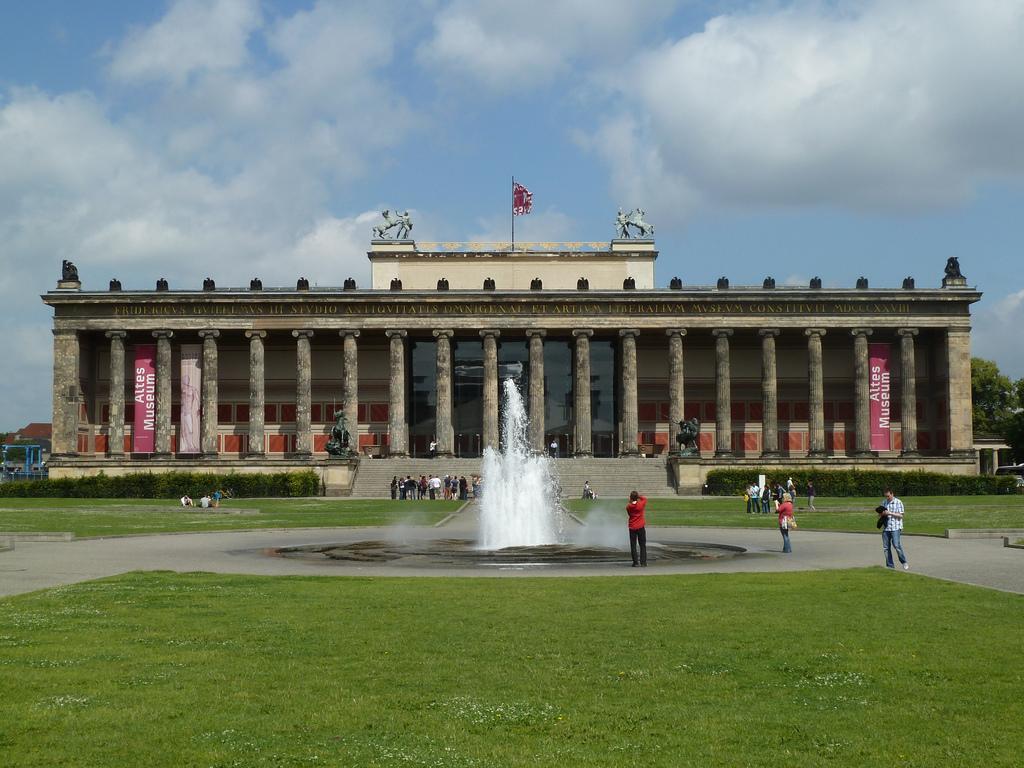Can you describe this image briefly? In the image we can see fort, pillars, banner, statues, flag, plant, stairs, grass, trees, water fountain and a cloudy sky. We can even see there are people, walking, standing and some of them are sitting, they are wearing clothes. 